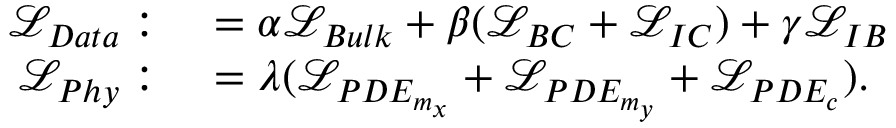Convert formula to latex. <formula><loc_0><loc_0><loc_500><loc_500>\begin{array} { r l } { \mathcal { L } _ { D a t a } \colon } & = \alpha \mathcal { L } _ { B u l k } + \beta ( \mathcal { L } _ { B C } + \mathcal { L } _ { I C } ) + \gamma \mathcal { L } _ { I B } } \\ { \mathcal { L } _ { P h y } \colon } & = \lambda ( \mathcal { L } _ { P D E _ { m _ { x } } } + \mathcal { L } _ { P D E _ { m _ { y } } } + \mathcal { L } _ { P D E _ { c } } ) . } \end{array}</formula> 